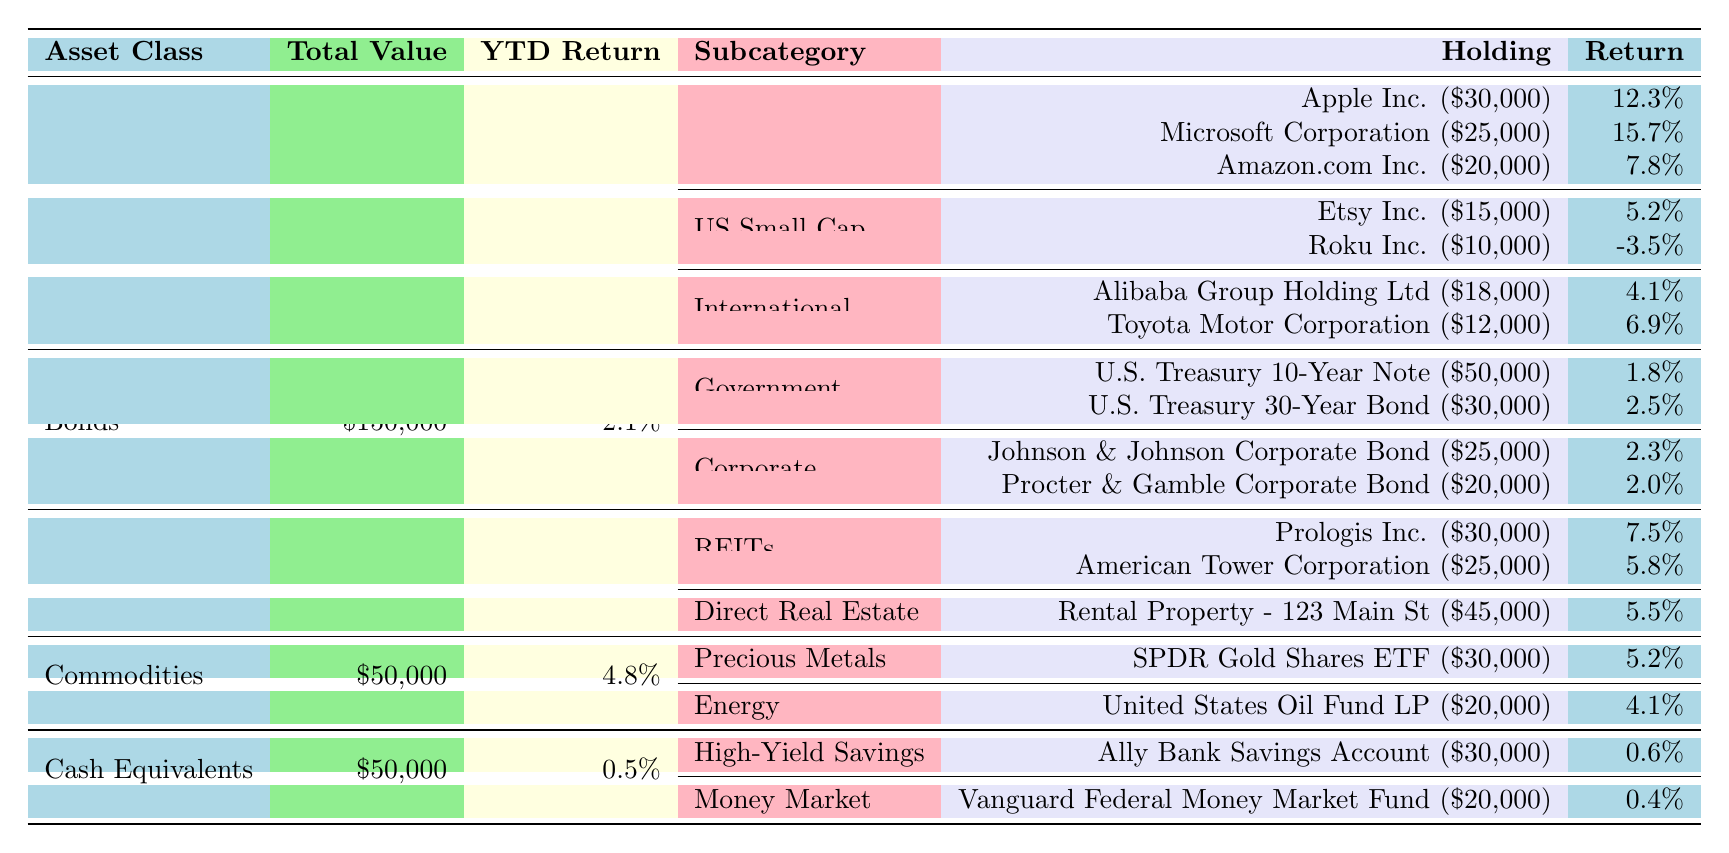What is the total value of Mary's investment in Stocks? The table lists the total value of the Stocks asset class as $250,000.
Answer: $250,000 What is the YTD return for Bonds? The table shows that the YTD return for the Bonds asset class is 2.1%.
Answer: 2.1% Which holding in the US Large Cap subcategory has the highest return? From the US Large Cap holdings, Microsoft Corporation has the highest return at 15.7%.
Answer: Microsoft Corporation What is the total value of all holdings in the Real Estate asset class? The total value for Real Estate is provided as $100,000 in the summary row of the asset class.
Answer: $100,000 What is the average return of the holdings within the US Small Cap subcategory? The returns for the holdings are 5.2% for Etsy Inc. and -3.5% for Roku Inc., which gives an average of (5.2 - 3.5) / 2 = 0.85%, accounting for two holdings.
Answer: 0.85% Which asset class has the highest total value? The asset class with the highest total value is Stocks, totaling $250,000.
Answer: Stocks Is the return on the U.S. Treasury 10-Year Note higher than that of the Procter & Gamble Corporate Bond? The U.S. Treasury 10-Year Note has a return of 1.8%, while Procter & Gamble Corporate Bond has a return of 2.0%, so the latter is higher.
Answer: No What is the total value of all US Large Cap Holdings? Summing the values: Apple Inc. ($30,000) + Microsoft Corporation ($25,000) + Amazon.com Inc. ($20,000) totals to $75,000.
Answer: $75,000 How much does the total investment in Precious Metals contribute to the overall investment portfolio? The Precious Metals investment is $30,000 within the Commodities asset class, whereas the total portfolio value is $250,000 + $150,000 + $100,000 + $50,000 + $50,000 = $600,000, making it 5% of the overall portfolio.
Answer: 5% Which subcategory in Real Estate has the best performing holding based on return? The REITs subcategory has Prologis Inc. with a return of 7.5%, which is higher than the Direct Real Estate holding return of 5.5%.
Answer: REITs 